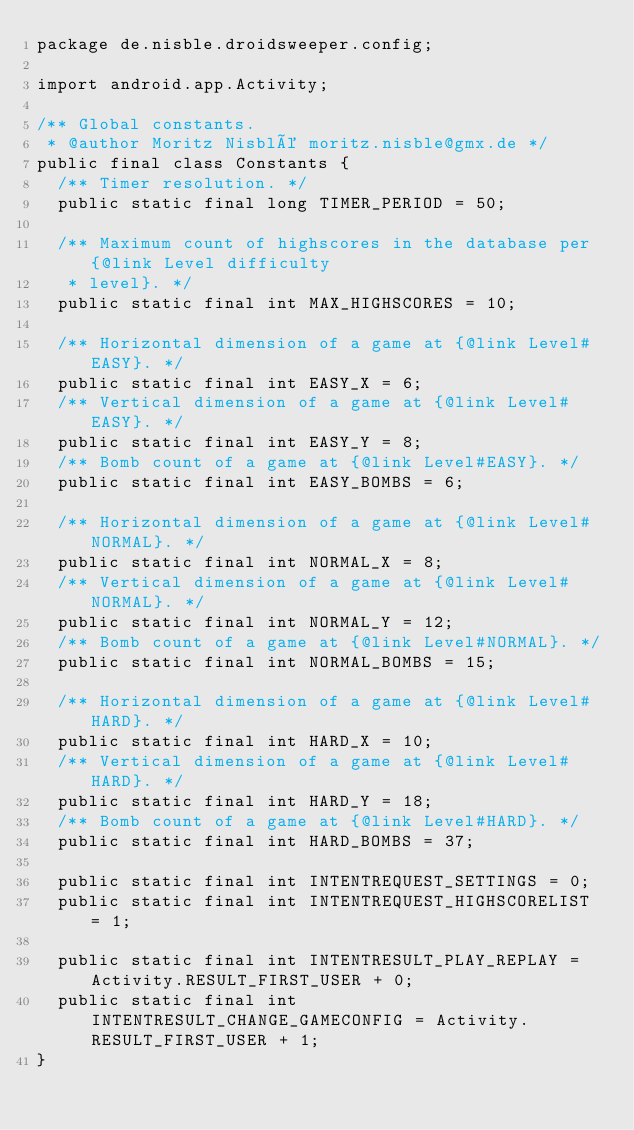Convert code to text. <code><loc_0><loc_0><loc_500><loc_500><_Java_>package de.nisble.droidsweeper.config;

import android.app.Activity;

/** Global constants.
 * @author Moritz Nisblé moritz.nisble@gmx.de */
public final class Constants {
	/** Timer resolution. */
	public static final long TIMER_PERIOD = 50;

	/** Maximum count of highscores in the database per {@link Level difficulty
	 * level}. */
	public static final int MAX_HIGHSCORES = 10;

	/** Horizontal dimension of a game at {@link Level#EASY}. */
	public static final int EASY_X = 6;
	/** Vertical dimension of a game at {@link Level#EASY}. */
	public static final int EASY_Y = 8;
	/** Bomb count of a game at {@link Level#EASY}. */
	public static final int EASY_BOMBS = 6;

	/** Horizontal dimension of a game at {@link Level#NORMAL}. */
	public static final int NORMAL_X = 8;
	/** Vertical dimension of a game at {@link Level#NORMAL}. */
	public static final int NORMAL_Y = 12;
	/** Bomb count of a game at {@link Level#NORMAL}. */
	public static final int NORMAL_BOMBS = 15;

	/** Horizontal dimension of a game at {@link Level#HARD}. */
	public static final int HARD_X = 10;
	/** Vertical dimension of a game at {@link Level#HARD}. */
	public static final int HARD_Y = 18;
	/** Bomb count of a game at {@link Level#HARD}. */
	public static final int HARD_BOMBS = 37;

	public static final int INTENTREQUEST_SETTINGS = 0;
	public static final int INTENTREQUEST_HIGHSCORELIST = 1;

	public static final int INTENTRESULT_PLAY_REPLAY = Activity.RESULT_FIRST_USER + 0;
	public static final int INTENTRESULT_CHANGE_GAMECONFIG = Activity.RESULT_FIRST_USER + 1;
}
</code> 